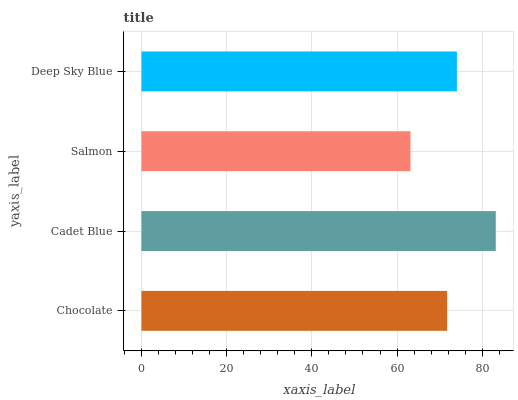Is Salmon the minimum?
Answer yes or no. Yes. Is Cadet Blue the maximum?
Answer yes or no. Yes. Is Cadet Blue the minimum?
Answer yes or no. No. Is Salmon the maximum?
Answer yes or no. No. Is Cadet Blue greater than Salmon?
Answer yes or no. Yes. Is Salmon less than Cadet Blue?
Answer yes or no. Yes. Is Salmon greater than Cadet Blue?
Answer yes or no. No. Is Cadet Blue less than Salmon?
Answer yes or no. No. Is Deep Sky Blue the high median?
Answer yes or no. Yes. Is Chocolate the low median?
Answer yes or no. Yes. Is Salmon the high median?
Answer yes or no. No. Is Deep Sky Blue the low median?
Answer yes or no. No. 